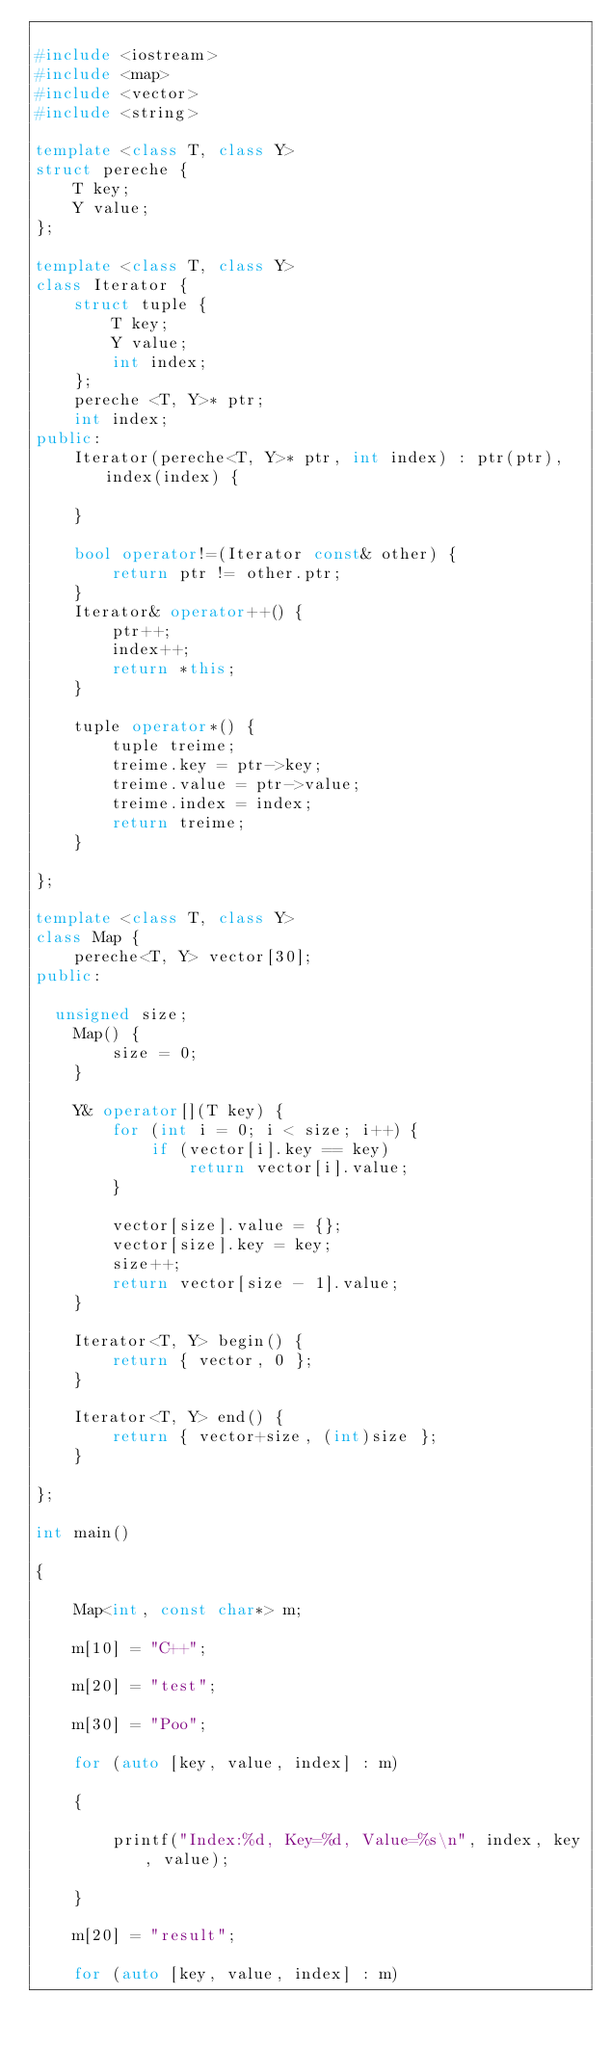Convert code to text. <code><loc_0><loc_0><loc_500><loc_500><_C++_>
#include <iostream>
#include <map>
#include <vector>
#include <string>

template <class T, class Y>
struct pereche {
    T key;
    Y value;
};

template <class T, class Y>
class Iterator {
    struct tuple {
        T key;
        Y value;
        int index;
    };
    pereche <T, Y>* ptr;
    int index;
public:
    Iterator(pereche<T, Y>* ptr, int index) : ptr(ptr), index(index) {

    }

    bool operator!=(Iterator const& other) {
        return ptr != other.ptr;
    }
    Iterator& operator++() {
        ptr++;
        index++;
        return *this;
    }
    
    tuple operator*() {
        tuple treime;
        treime.key = ptr->key;
        treime.value = ptr->value;
        treime.index = index;
        return treime;
    }

};

template <class T, class Y>
class Map {
    pereche<T, Y> vector[30];
public:

	unsigned size;
    Map() {
        size = 0;
    }

    Y& operator[](T key) {
        for (int i = 0; i < size; i++) {
            if (vector[i].key == key)
                return vector[i].value;
        }

        vector[size].value = {};
        vector[size].key = key;
        size++;
        return vector[size - 1].value;
    }

    Iterator<T, Y> begin() {
        return { vector, 0 };
    }

    Iterator<T, Y> end() {
        return { vector+size, (int)size };
    }

};

int main()

{

    Map<int, const char*> m;

    m[10] = "C++";

    m[20] = "test";

    m[30] = "Poo";

    for (auto [key, value, index] : m)

    {

        printf("Index:%d, Key=%d, Value=%s\n", index, key, value);

    }

    m[20] = "result";

    for (auto [key, value, index] : m)
</code> 